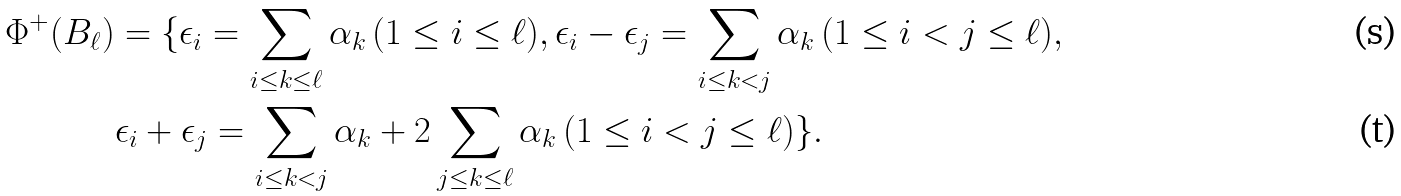Convert formula to latex. <formula><loc_0><loc_0><loc_500><loc_500>\Phi ^ { + } ( B _ { \ell } ) & = \{ \epsilon _ { i } = \sum _ { i \leq k \leq \ell } \alpha _ { k } \, ( 1 \leq i \leq \ell ) , \epsilon _ { i } - \epsilon _ { j } = \sum _ { i \leq k < j } \alpha _ { k } \, ( 1 \leq i < j \leq \ell ) , \\ & \epsilon _ { i } + \epsilon _ { j } = \sum _ { i \leq k < j } \alpha _ { k } + 2 \sum _ { j \leq k \leq \ell } \alpha _ { k } \, ( 1 \leq i < j \leq \ell ) \} .</formula> 